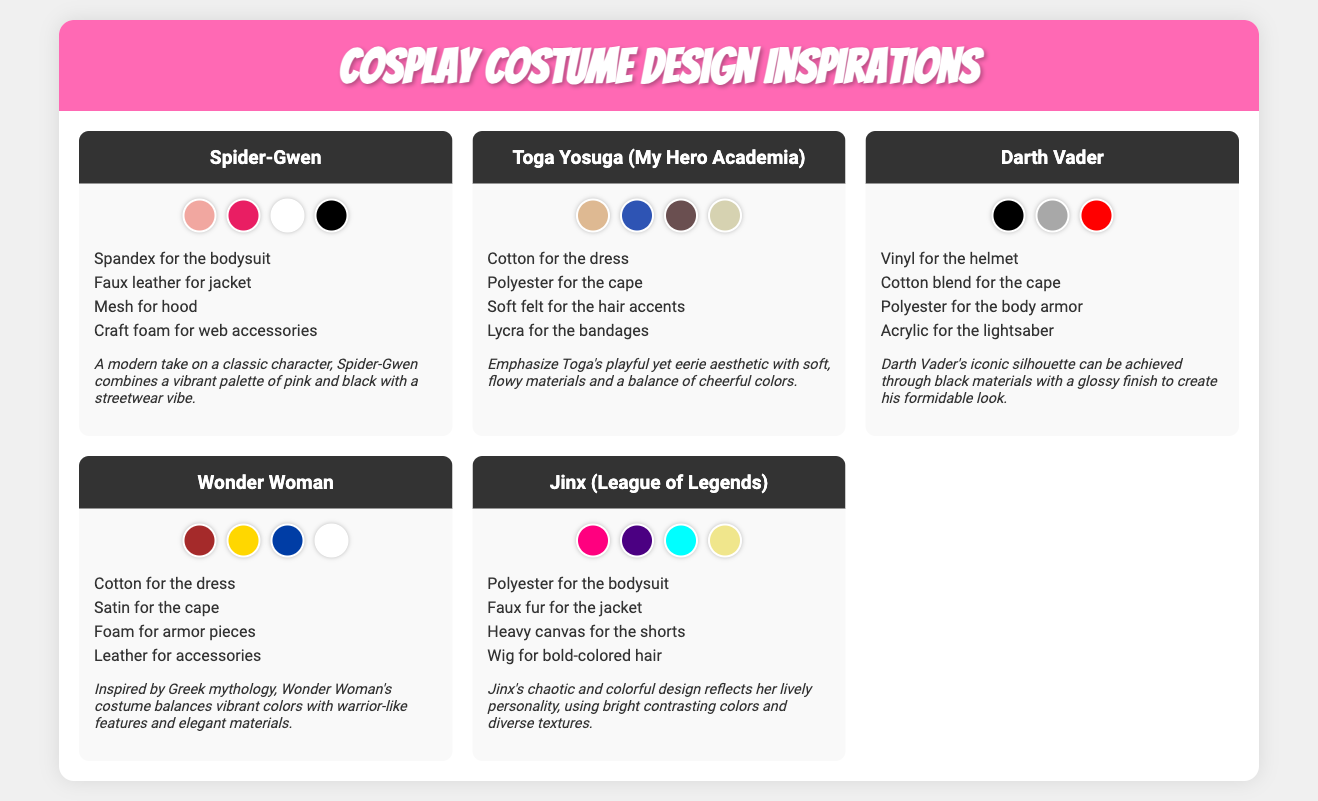What character features a vibrant palette of pink and black? The document lists Spider-Gwen as having a vibrant palette of pink and black.
Answer: Spider-Gwen Which material is suggested for the bodysuit of Jinx? The document indicates polyester as the material for Jinx's bodysuit.
Answer: Polyester How many color swatches are provided for Darth Vader? The document includes three color swatches for Darth Vader.
Answer: Three What type of fabric is recommended for Wonder Woman's armor pieces? Foam is suggested as the material for Wonder Woman's armor pieces.
Answer: Foam Which character's design reflects a playful yet eerie aesthetic? The document states that Toga Yosuga's design reflects a playful yet eerie aesthetic.
Answer: Toga Yosuga What is the primary color associated with Jinx's character design? The color associated with Jinx's character design is bright pink, as shown in the color swatch.
Answer: Bright pink Which material is suggested for the cape of Darth Vader? The document recommends a cotton blend for Darth Vader's cape.
Answer: Cotton blend 